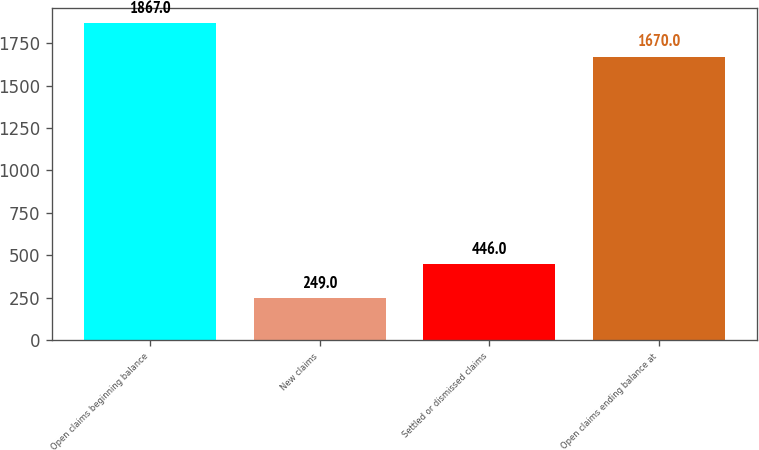Convert chart. <chart><loc_0><loc_0><loc_500><loc_500><bar_chart><fcel>Open claims beginning balance<fcel>New claims<fcel>Settled or dismissed claims<fcel>Open claims ending balance at<nl><fcel>1867<fcel>249<fcel>446<fcel>1670<nl></chart> 